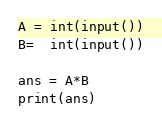Convert code to text. <code><loc_0><loc_0><loc_500><loc_500><_Python_>A = int(input())
B=  int(input())

ans = A*B
print(ans)</code> 